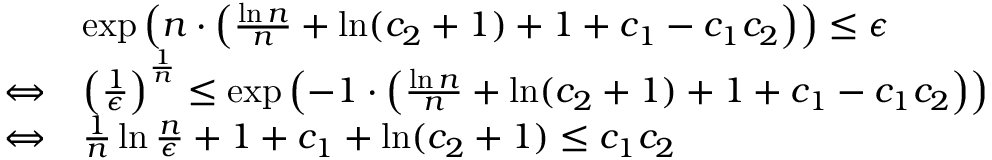<formula> <loc_0><loc_0><loc_500><loc_500>\begin{array} { r l } & { \exp \left ( n \cdot \left ( \frac { \ln n } { n } + \ln ( c _ { 2 } + 1 ) + 1 + c _ { 1 } - c _ { 1 } c _ { 2 } \right ) \right ) \leq \epsilon } \\ { \Leftrightarrow } & { \left ( \frac { 1 } { \epsilon } \right ) ^ { \frac { 1 } { n } } \leq \exp \left ( - 1 \cdot \left ( \frac { \ln n } { n } + \ln ( c _ { 2 } + 1 ) + 1 + c _ { 1 } - c _ { 1 } c _ { 2 } \right ) \right ) } \\ { \Leftrightarrow } & { \frac { 1 } { n } \ln \frac { n } { \epsilon } + 1 + c _ { 1 } + \ln ( c _ { 2 } + 1 ) \leq c _ { 1 } c _ { 2 } } \end{array}</formula> 